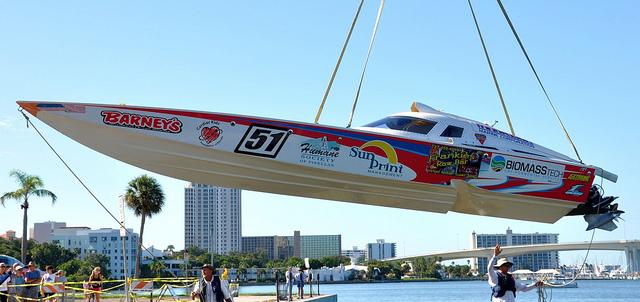What number is on the boat?
Answer briefly. 51. Is the boat been lifted?
Write a very short answer. Yes. What is pictured next to Barney's on the boat?
Short answer required. Heart. 